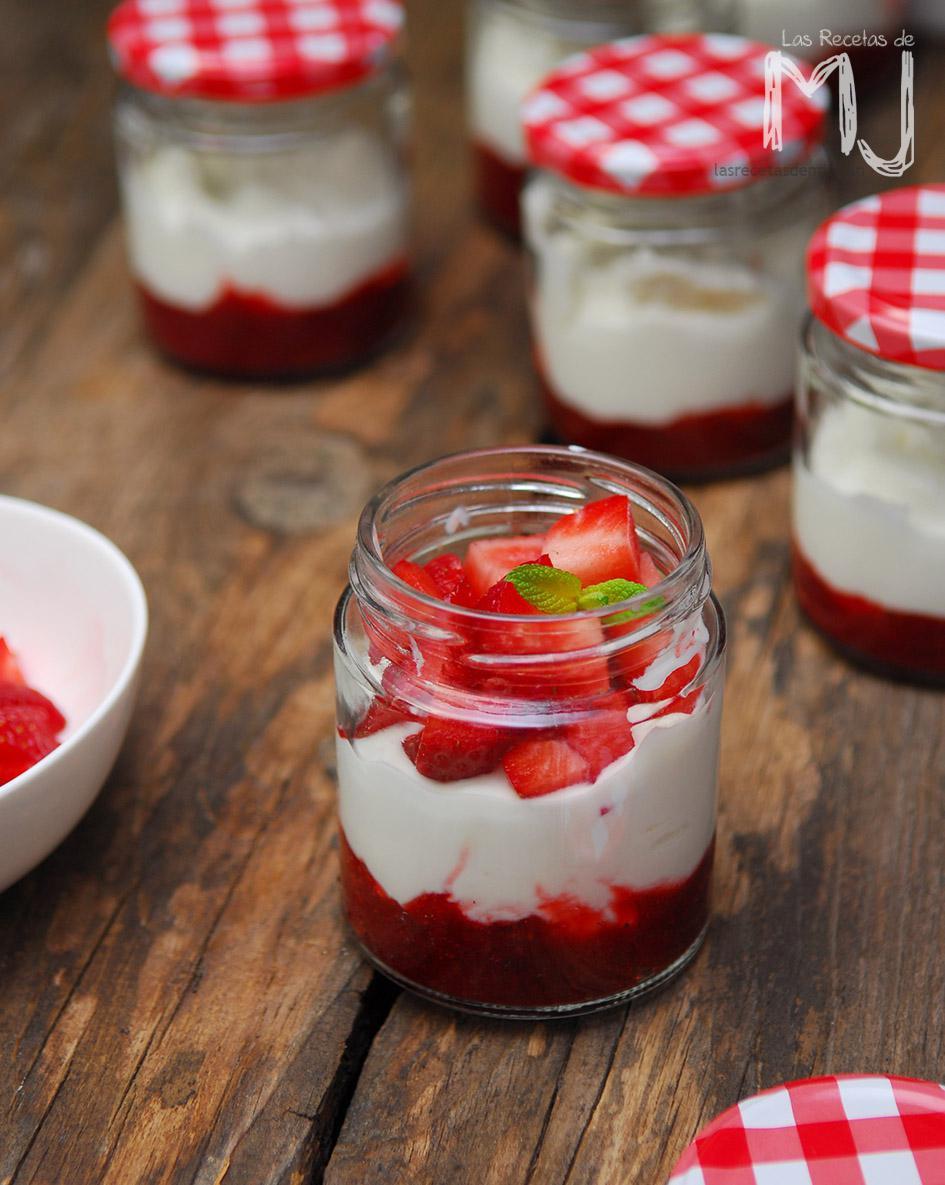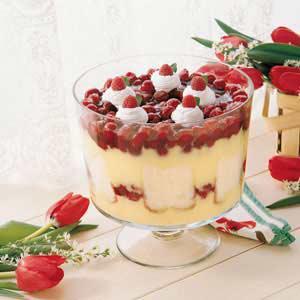The first image is the image on the left, the second image is the image on the right. For the images shown, is this caption "An image shows a dessert topped with red berries and served in a stout footed glass." true? Answer yes or no. Yes. The first image is the image on the left, the second image is the image on the right. Given the left and right images, does the statement "There is exactly one dessert in an open jar in one of the images" hold true? Answer yes or no. Yes. 